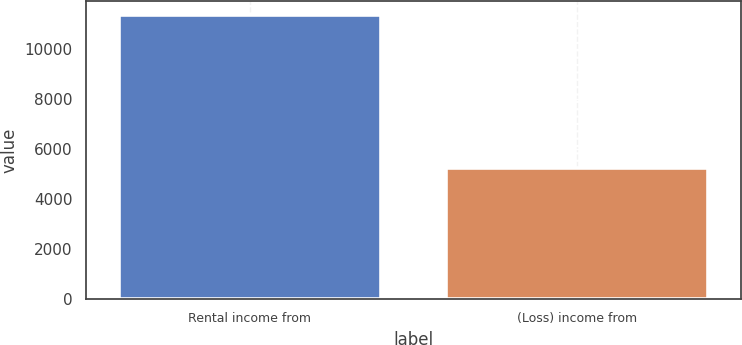Convert chart. <chart><loc_0><loc_0><loc_500><loc_500><bar_chart><fcel>Rental income from<fcel>(Loss) income from<nl><fcel>11351<fcel>5246<nl></chart> 